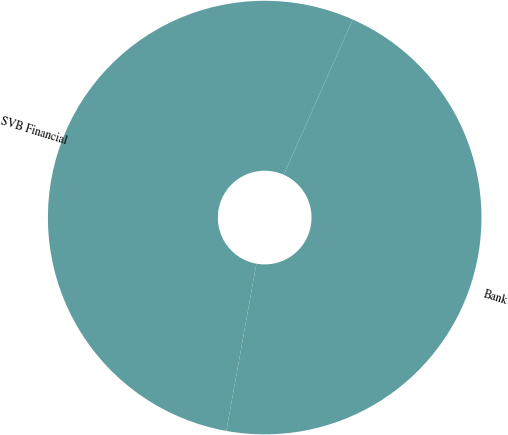<chart> <loc_0><loc_0><loc_500><loc_500><pie_chart><fcel>SVB Financial<fcel>Bank<nl><fcel>53.83%<fcel>46.17%<nl></chart> 